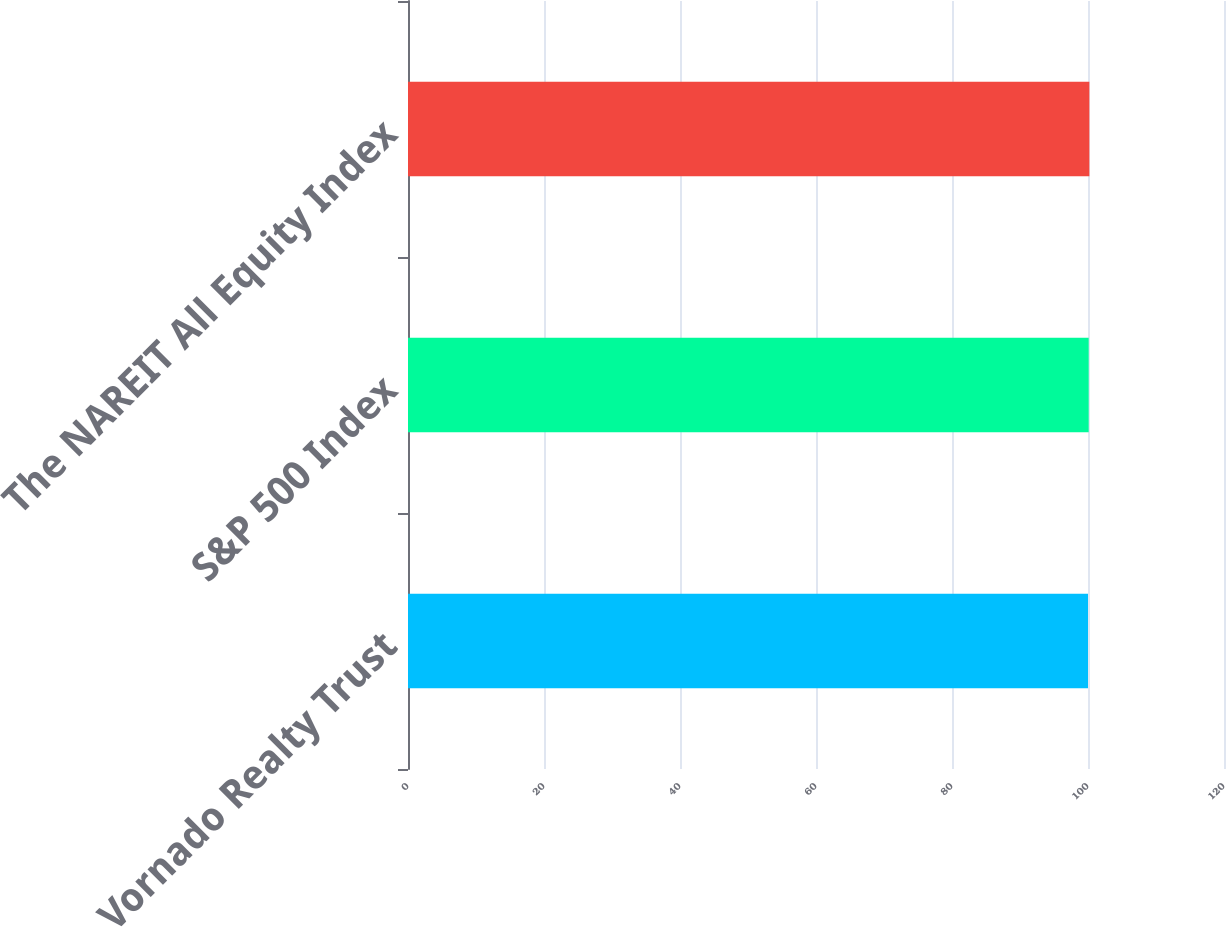<chart> <loc_0><loc_0><loc_500><loc_500><bar_chart><fcel>Vornado Realty Trust<fcel>S&P 500 Index<fcel>The NAREIT All Equity Index<nl><fcel>100<fcel>100.1<fcel>100.2<nl></chart> 